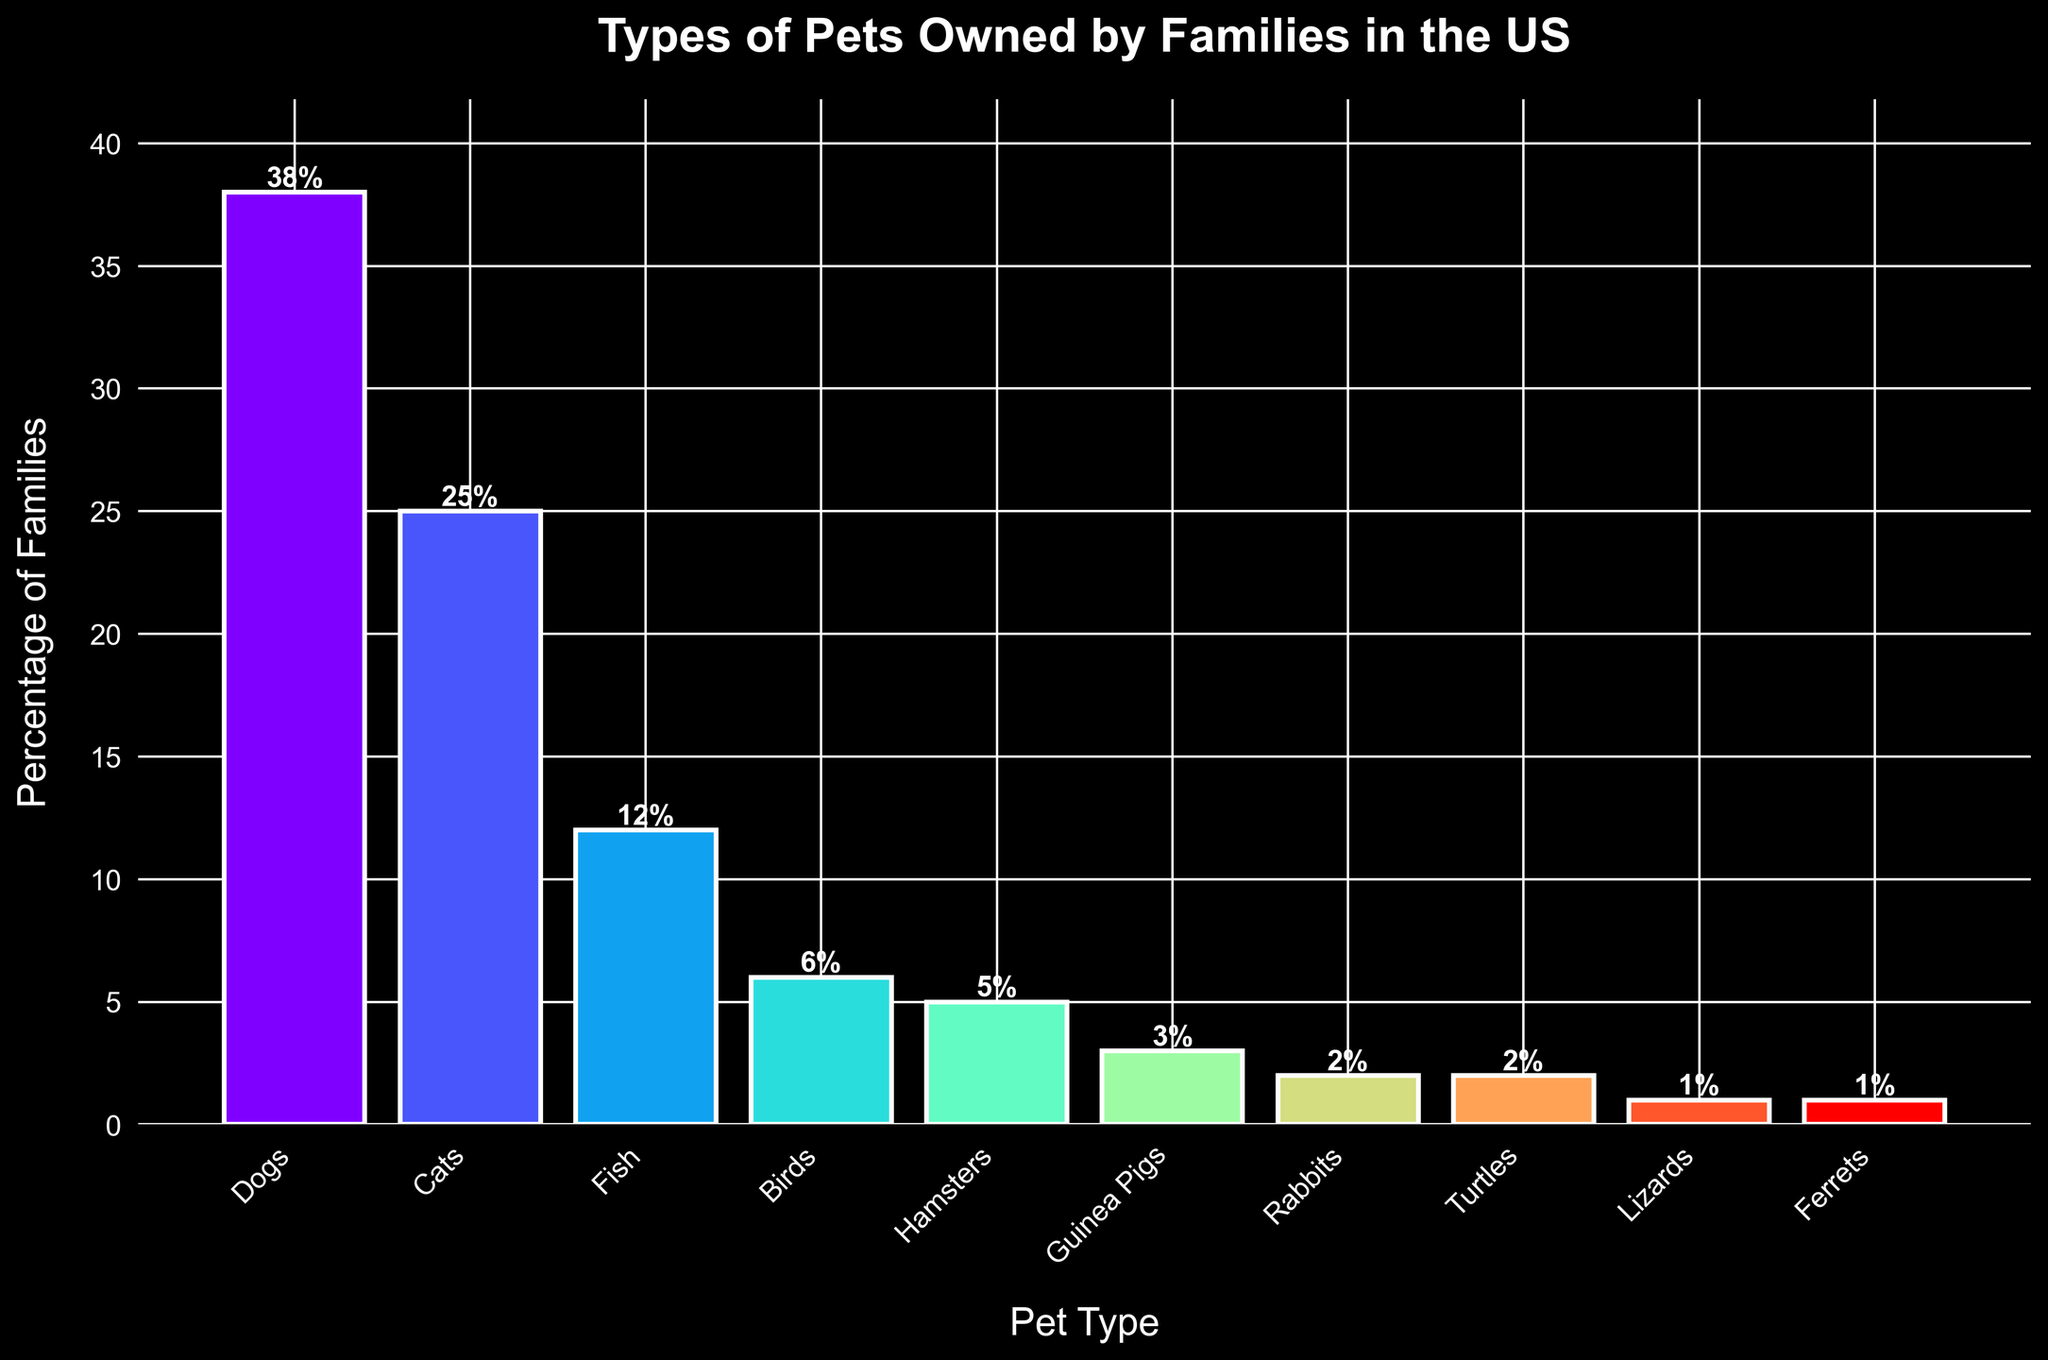Which pet type is owned by the highest percentage of families? The bar for "Dogs" is the tallest bar in the chart, indicating it is the most owned pet. It reaches up to 38% on the y-axis.
Answer: Dogs Which two pet types have a combined ownership percentage of 7%? From the chart, the bar for "Hamsters" is at 5% and the bar for "Guinea Pigs" is at 3%. Combining these, 5% + 3% = 8%. This is closest to the required 7%.
Answer: Hamsters and Guinea Pigs What is the difference in the percentages of families owning Dogs and Cats? The height of the Dog bar is 38% and the Cat bar is 25%. Subtract 25% from 38%, which gives 38% - 25% = 13%.
Answer: 13% Which pet is owned by the smallest percentage of families? The bars for "Lizards" and "Ferrets" are the shortest, each reaching 1% on the y-axis.
Answer: Lizards and Ferrets How many pet types are owned by 5% or more families? Looking at the chart, the bars for "Dogs" (38%), "Cats" (25%), "Fish" (12%), "Birds" (6%), and "Hamsters" (5%) are 5% or higher. Count them, there are 5 such pet types.
Answer: 5 Compare the percentage of families owning Fish to those owning Birds. Which is higher, and by how much? The height of the Fish bar is 12% and the Birds bar is 6%. 12% - 6% = 6%, so Fish is higher by 6%.
Answer: Fish, 6% What is the total percentage of families that own either Turtles or Rabbits? Both Turtles and Rabbits have bars at 2% each. Combine these, 2% + 2% = 4%.
Answer: 4% Which pet types are owned by equal percentages of families? The chart shows Turtles and Rabbits each at 2%, and Lizards and Ferrets each at 1%, indicating they are owned by equal percentages.
Answer: Turtles and Rabbits; Lizards and Ferrets What is the average percentage of families owning Cats, Fish, and Birds? The bars for Cats, Fish, and Birds are at 25%, 12%, and 6% respectively. Add these totals: 25% + 12% + 6% = 43%, then divide by the number of pet types (3). The average is 43% ÷ 3 ≈ 14.33%.
Answer: 14.33% 